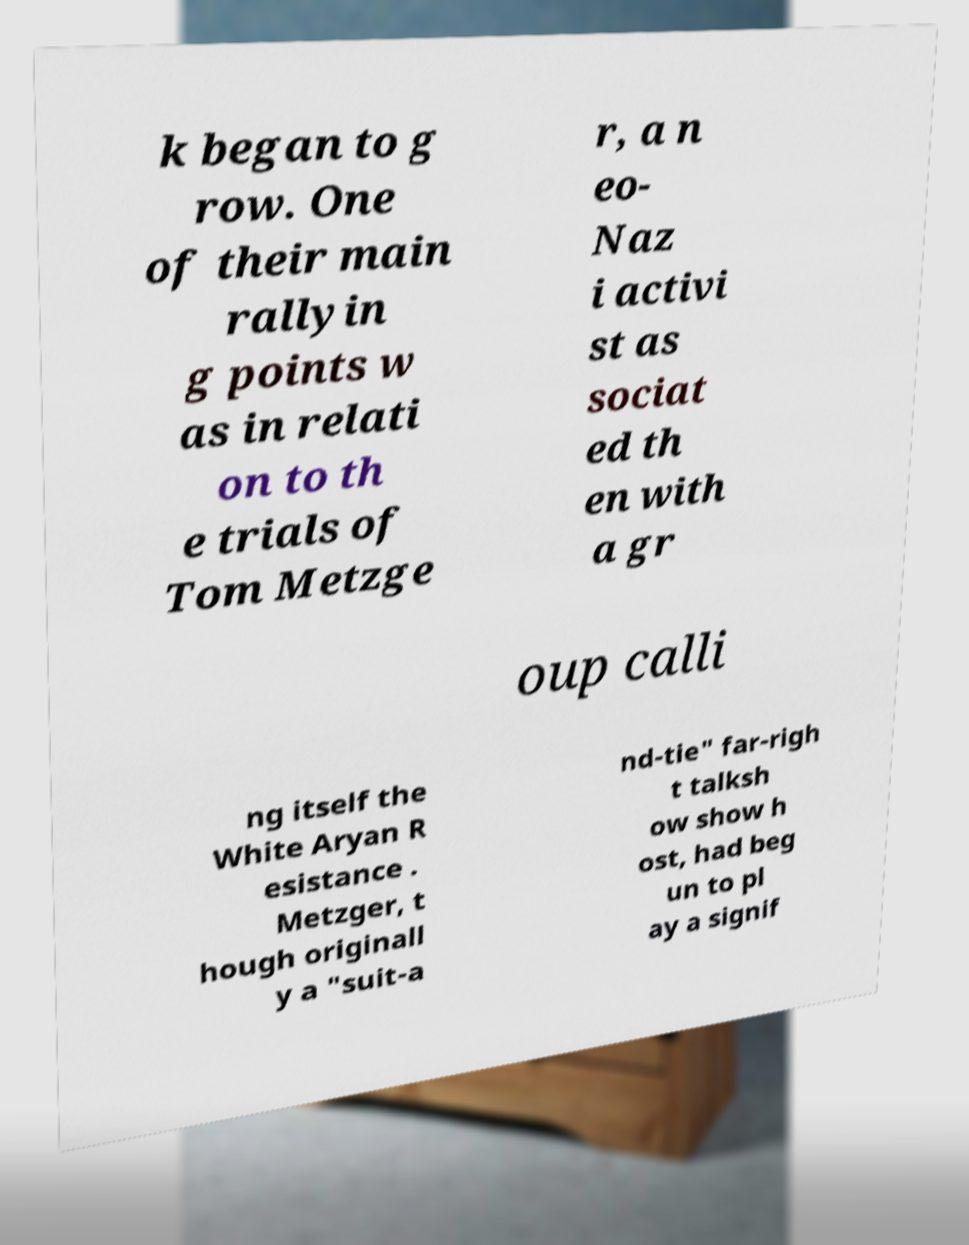Please identify and transcribe the text found in this image. k began to g row. One of their main rallyin g points w as in relati on to th e trials of Tom Metzge r, a n eo- Naz i activi st as sociat ed th en with a gr oup calli ng itself the White Aryan R esistance . Metzger, t hough originall y a "suit-a nd-tie" far-righ t talksh ow show h ost, had beg un to pl ay a signif 